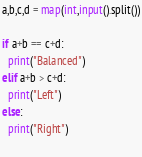Convert code to text. <code><loc_0><loc_0><loc_500><loc_500><_Python_>a,b,c,d = map(int,input().split())

if a+b == c+d:
  print("Balanced")
elif a+b > c+d:
  print("Left")
else:
  print("Right")
  </code> 